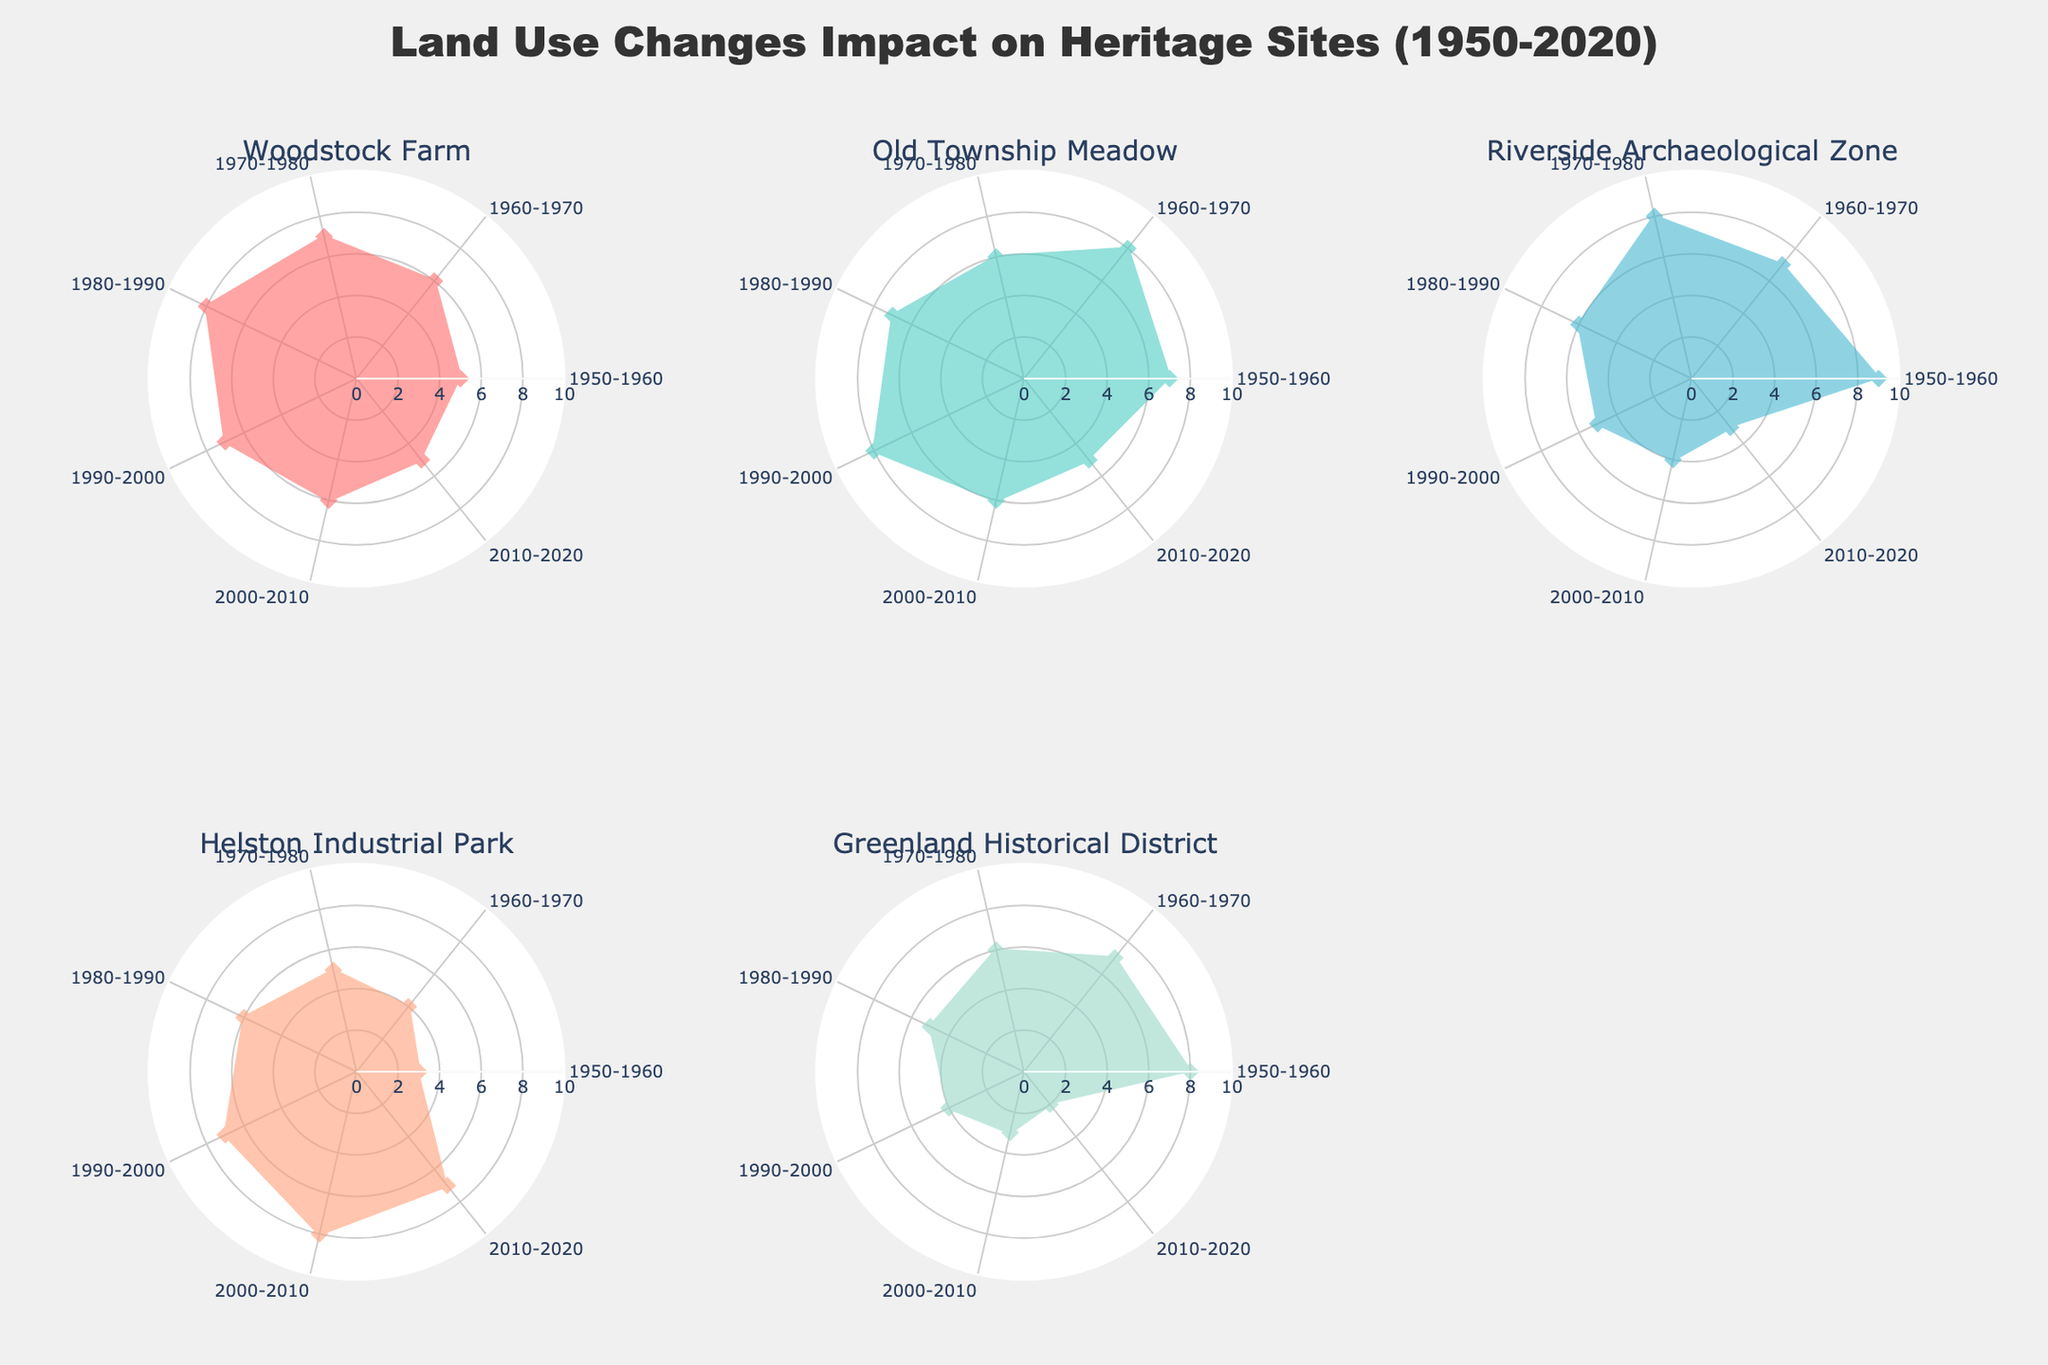What is the title of the figure? The title is typically placed at the top center of the figure. It summarizes the content and purpose of the visual representation.
Answer: Land Use Changes Impact on Heritage Sites (1950-2020) Which site shows the highest land use change during the 1950-1960 decade? By looking at the radar chart for each site, note the spokes corresponding to the 1950-1960 decade and compare their lengths. The longest spoke indicates the highest land use change.
Answer: Riverside Archaeological Zone How does the land use change in the Greenland Historical District evolve over the decades? Observe the radar chart for the Greenland Historical District and trace the length of the spokes from 1950 to 2020. Notice whether the spokes increase, decrease, or remain constant over time.
Answer: It decreases steadily Which two sites show a similar trend in land use change from 2000 to 2020? Compare the radar charts for each site focusing on the last two decades (2000-2010 and 2010-2020). Identify two sites whose spokes exhibit similar patterns in length and direction.
Answer: Woodstock Farm and Old Township Meadow By how much did the land use for Helston Industrial Park change from the 1960-1970 to the 1980-1990 decade? Look at the lengths of the spokes for Helston Industrial Park corresponding to 1960-1970 and 1980-1990. Calculate the difference between these two values.
Answer: It increased by 2 units (4 to 6) Which decade shows the maximum land use for the Old Township Meadow? Inspect the lengths of the spokes for the Old Township Meadow across all decades. The longest spoke represents the decade with the maximum land use.
Answer: 1960-1970 Are there any sites where the land use is consistently decreasing from 1950 to 2020? Examine trends for each site across decades. For consistent decrease, spokes should steadily get shorter from 1950-1960 to 2010-2020.
Answer: Greenland Historical District Compare the land use in Riverside Archaeological Zone and Helston Industrial Park for the 1990-2000 decade. Which one experienced higher land use? Compare the lengths of spokes corresponding to the 1990-2000 decade for both sites. The longer spoke indicates higher land use.
Answer: Helston Industrial Park What is the average land use value for Woodstock Farm across all decades? Sum the land use values for Woodstock Farm across all decades and divide by the number of decades (7). (5+6+7+8+7+6+5)/7
Answer: 6.3 